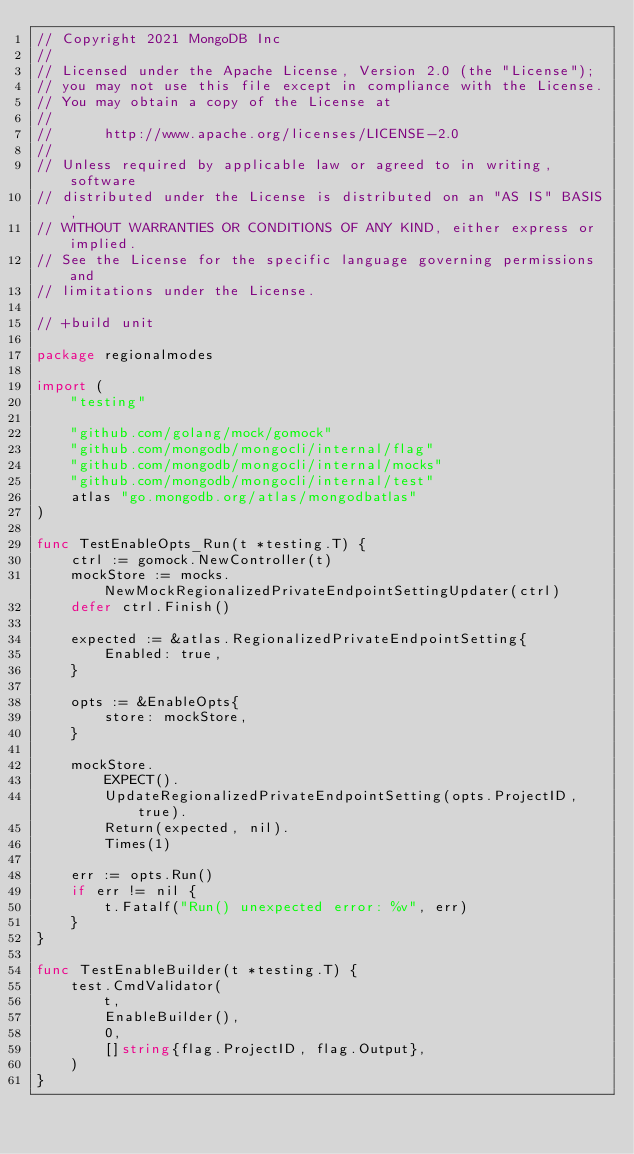Convert code to text. <code><loc_0><loc_0><loc_500><loc_500><_Go_>// Copyright 2021 MongoDB Inc
//
// Licensed under the Apache License, Version 2.0 (the "License");
// you may not use this file except in compliance with the License.
// You may obtain a copy of the License at
//
//      http://www.apache.org/licenses/LICENSE-2.0
//
// Unless required by applicable law or agreed to in writing, software
// distributed under the License is distributed on an "AS IS" BASIS,
// WITHOUT WARRANTIES OR CONDITIONS OF ANY KIND, either express or implied.
// See the License for the specific language governing permissions and
// limitations under the License.

// +build unit

package regionalmodes

import (
	"testing"

	"github.com/golang/mock/gomock"
	"github.com/mongodb/mongocli/internal/flag"
	"github.com/mongodb/mongocli/internal/mocks"
	"github.com/mongodb/mongocli/internal/test"
	atlas "go.mongodb.org/atlas/mongodbatlas"
)

func TestEnableOpts_Run(t *testing.T) {
	ctrl := gomock.NewController(t)
	mockStore := mocks.NewMockRegionalizedPrivateEndpointSettingUpdater(ctrl)
	defer ctrl.Finish()

	expected := &atlas.RegionalizedPrivateEndpointSetting{
		Enabled: true,
	}

	opts := &EnableOpts{
		store: mockStore,
	}

	mockStore.
		EXPECT().
		UpdateRegionalizedPrivateEndpointSetting(opts.ProjectID, true).
		Return(expected, nil).
		Times(1)

	err := opts.Run()
	if err != nil {
		t.Fatalf("Run() unexpected error: %v", err)
	}
}

func TestEnableBuilder(t *testing.T) {
	test.CmdValidator(
		t,
		EnableBuilder(),
		0,
		[]string{flag.ProjectID, flag.Output},
	)
}
</code> 